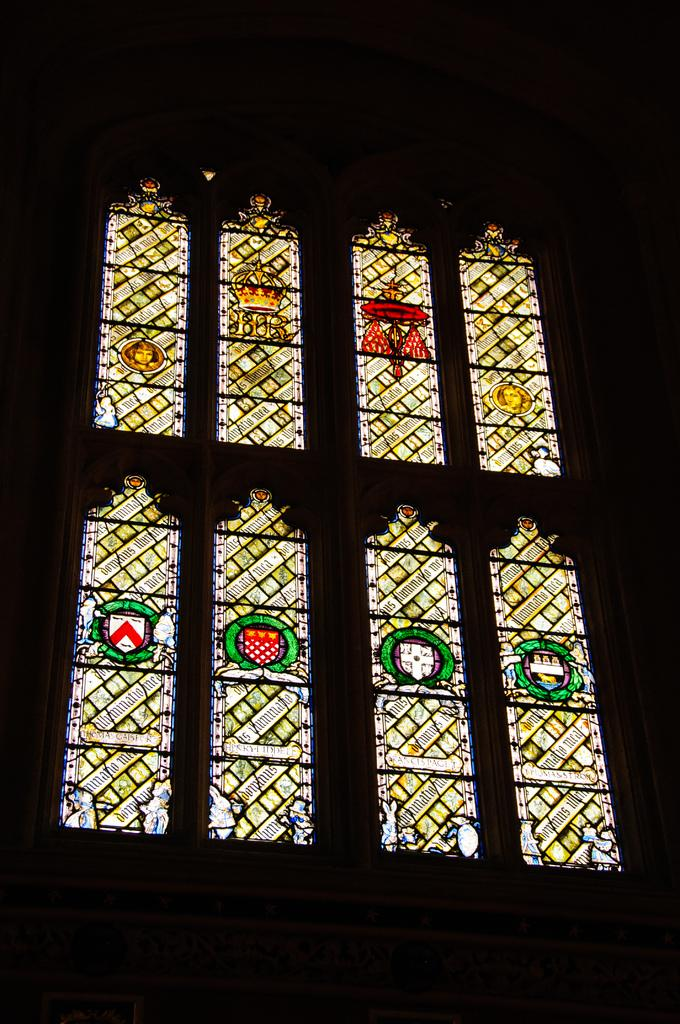What can be seen on the wall in the image? There are windows on the wall in the image. Can you describe the windows in the image? The windows are visible on the wall in the image. What type of hobbies do the bushes in the image enjoy? There are no bushes present in the image, so it is not possible to determine their hobbies. 